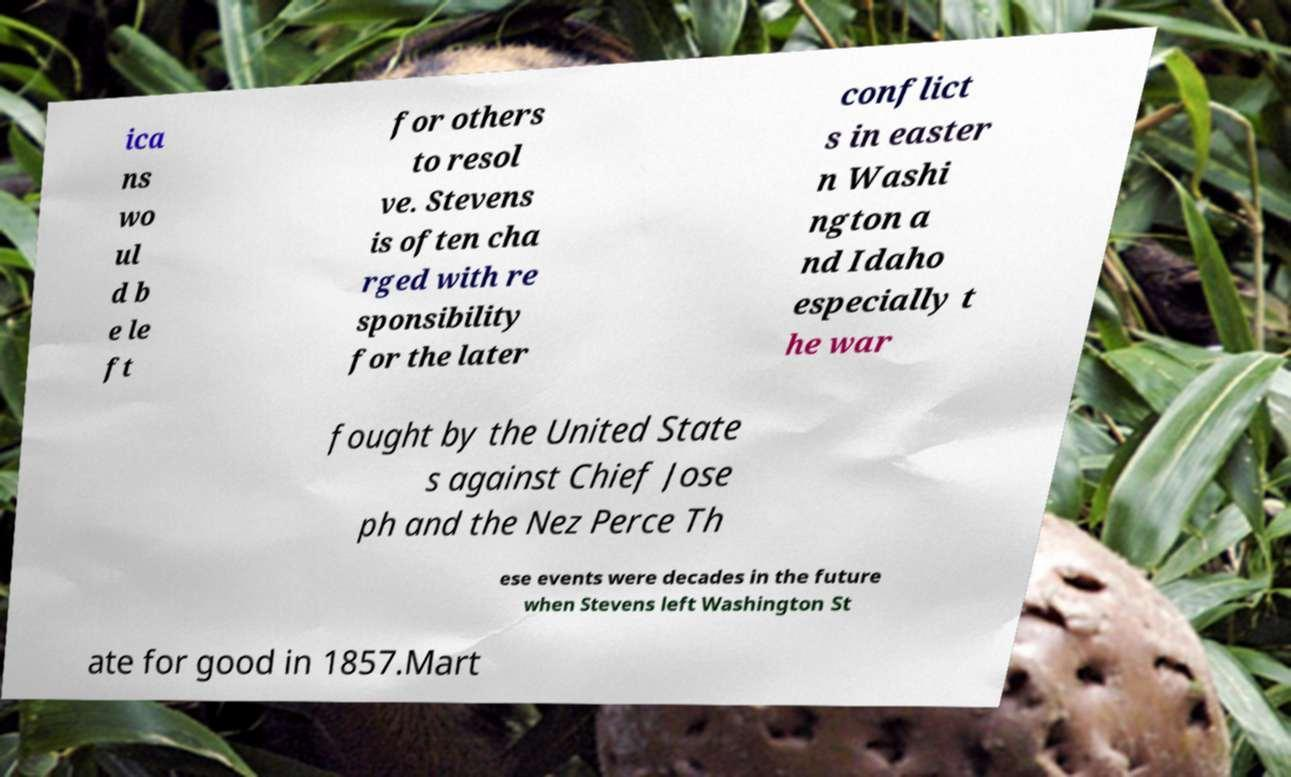I need the written content from this picture converted into text. Can you do that? ica ns wo ul d b e le ft for others to resol ve. Stevens is often cha rged with re sponsibility for the later conflict s in easter n Washi ngton a nd Idaho especially t he war fought by the United State s against Chief Jose ph and the Nez Perce Th ese events were decades in the future when Stevens left Washington St ate for good in 1857.Mart 